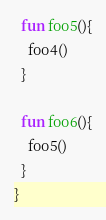Convert code to text. <code><loc_0><loc_0><loc_500><loc_500><_Kotlin_>
  fun foo5(){
    foo4()
  }

  fun foo6(){
    foo5()
  }
}</code> 